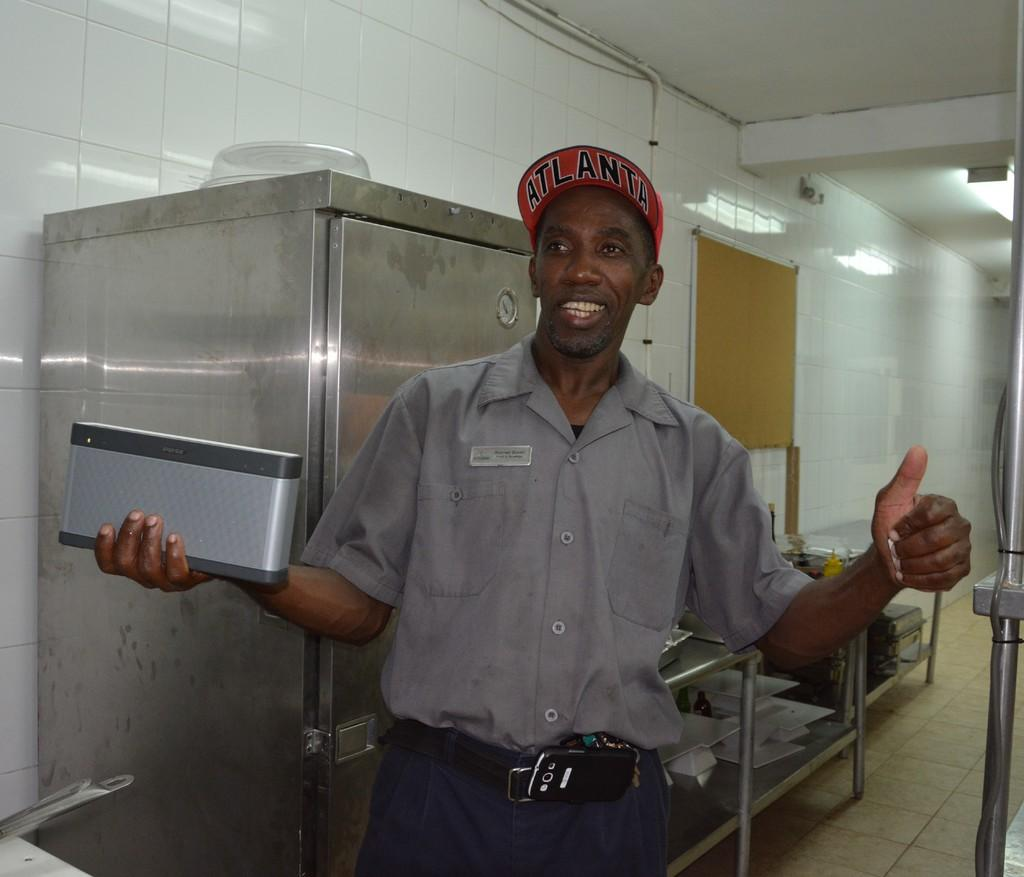<image>
Relay a brief, clear account of the picture shown. A man is wearing an Atlanta hat and holding a Bose product. 